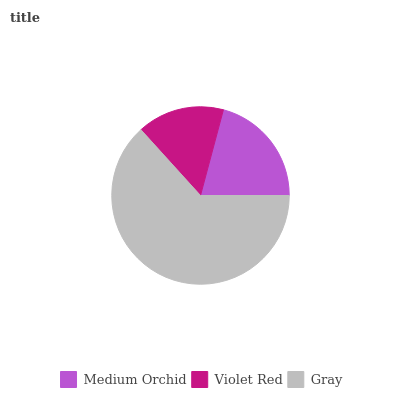Is Violet Red the minimum?
Answer yes or no. Yes. Is Gray the maximum?
Answer yes or no. Yes. Is Gray the minimum?
Answer yes or no. No. Is Violet Red the maximum?
Answer yes or no. No. Is Gray greater than Violet Red?
Answer yes or no. Yes. Is Violet Red less than Gray?
Answer yes or no. Yes. Is Violet Red greater than Gray?
Answer yes or no. No. Is Gray less than Violet Red?
Answer yes or no. No. Is Medium Orchid the high median?
Answer yes or no. Yes. Is Medium Orchid the low median?
Answer yes or no. Yes. Is Violet Red the high median?
Answer yes or no. No. Is Violet Red the low median?
Answer yes or no. No. 